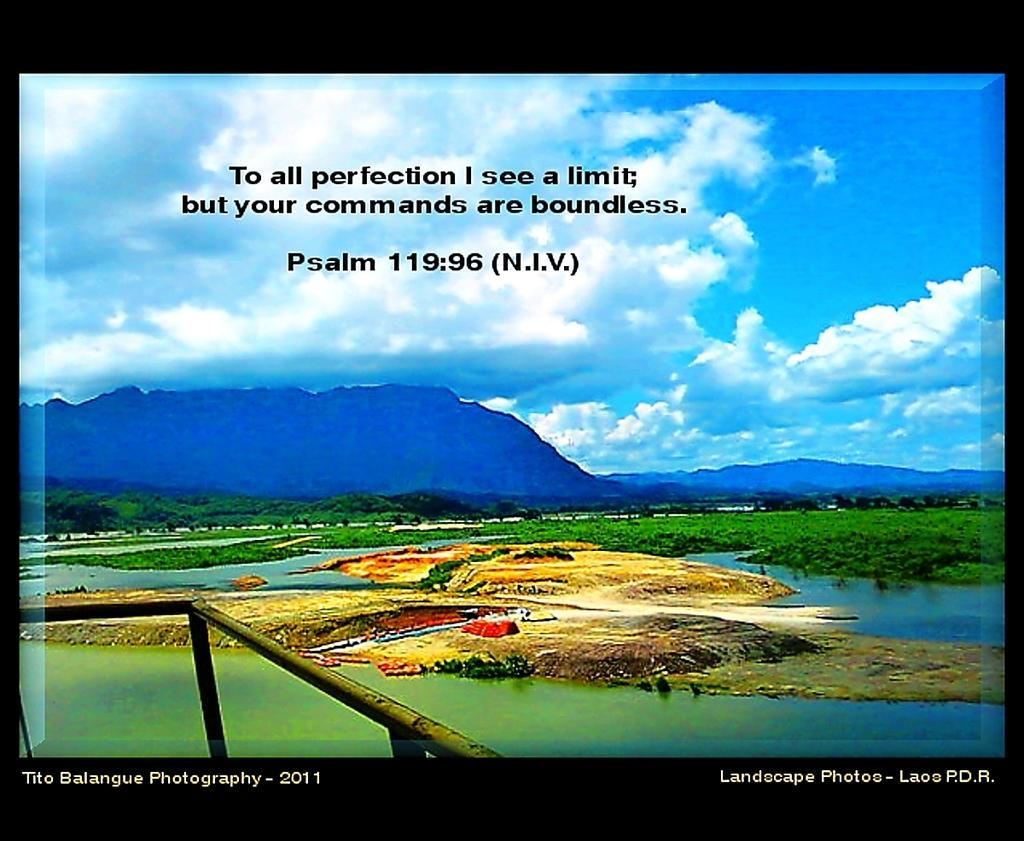<image>
Share a concise interpretation of the image provided. A poster that says "To all perfection I see a limit; but your commands are boundless.". 